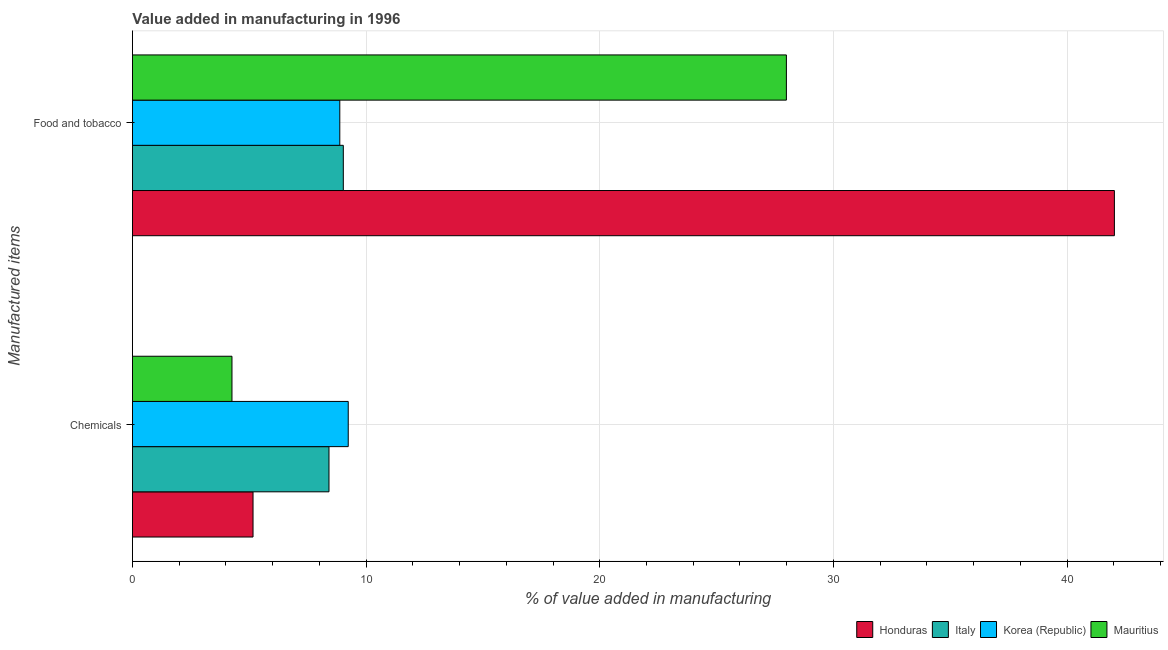How many groups of bars are there?
Offer a terse response. 2. How many bars are there on the 2nd tick from the bottom?
Give a very brief answer. 4. What is the label of the 1st group of bars from the top?
Offer a very short reply. Food and tobacco. What is the value added by  manufacturing chemicals in Honduras?
Offer a terse response. 5.16. Across all countries, what is the maximum value added by  manufacturing chemicals?
Make the answer very short. 9.24. Across all countries, what is the minimum value added by  manufacturing chemicals?
Keep it short and to the point. 4.26. In which country was the value added by  manufacturing chemicals maximum?
Offer a very short reply. Korea (Republic). In which country was the value added by  manufacturing chemicals minimum?
Give a very brief answer. Mauritius. What is the total value added by manufacturing food and tobacco in the graph?
Your response must be concise. 87.91. What is the difference between the value added by manufacturing food and tobacco in Italy and that in Honduras?
Offer a terse response. -33. What is the difference between the value added by manufacturing food and tobacco in Mauritius and the value added by  manufacturing chemicals in Italy?
Offer a terse response. 19.58. What is the average value added by manufacturing food and tobacco per country?
Provide a short and direct response. 21.98. What is the difference between the value added by manufacturing food and tobacco and value added by  manufacturing chemicals in Italy?
Your response must be concise. 0.61. In how many countries, is the value added by  manufacturing chemicals greater than 2 %?
Offer a terse response. 4. What is the ratio of the value added by  manufacturing chemicals in Honduras to that in Korea (Republic)?
Your response must be concise. 0.56. In how many countries, is the value added by manufacturing food and tobacco greater than the average value added by manufacturing food and tobacco taken over all countries?
Keep it short and to the point. 2. What does the 4th bar from the top in Chemicals represents?
Provide a succinct answer. Honduras. How many bars are there?
Give a very brief answer. 8. Are all the bars in the graph horizontal?
Offer a terse response. Yes. How many countries are there in the graph?
Your answer should be compact. 4. What is the difference between two consecutive major ticks on the X-axis?
Ensure brevity in your answer.  10. Are the values on the major ticks of X-axis written in scientific E-notation?
Your answer should be very brief. No. Does the graph contain any zero values?
Offer a very short reply. No. Where does the legend appear in the graph?
Offer a terse response. Bottom right. How are the legend labels stacked?
Provide a succinct answer. Horizontal. What is the title of the graph?
Keep it short and to the point. Value added in manufacturing in 1996. What is the label or title of the X-axis?
Provide a short and direct response. % of value added in manufacturing. What is the label or title of the Y-axis?
Offer a very short reply. Manufactured items. What is the % of value added in manufacturing of Honduras in Chemicals?
Offer a very short reply. 5.16. What is the % of value added in manufacturing of Italy in Chemicals?
Give a very brief answer. 8.41. What is the % of value added in manufacturing of Korea (Republic) in Chemicals?
Provide a short and direct response. 9.24. What is the % of value added in manufacturing of Mauritius in Chemicals?
Keep it short and to the point. 4.26. What is the % of value added in manufacturing in Honduras in Food and tobacco?
Ensure brevity in your answer.  42.03. What is the % of value added in manufacturing in Italy in Food and tobacco?
Your answer should be very brief. 9.03. What is the % of value added in manufacturing in Korea (Republic) in Food and tobacco?
Ensure brevity in your answer.  8.87. What is the % of value added in manufacturing of Mauritius in Food and tobacco?
Keep it short and to the point. 27.99. Across all Manufactured items, what is the maximum % of value added in manufacturing in Honduras?
Your answer should be compact. 42.03. Across all Manufactured items, what is the maximum % of value added in manufacturing of Italy?
Offer a very short reply. 9.03. Across all Manufactured items, what is the maximum % of value added in manufacturing of Korea (Republic)?
Provide a short and direct response. 9.24. Across all Manufactured items, what is the maximum % of value added in manufacturing of Mauritius?
Your answer should be very brief. 27.99. Across all Manufactured items, what is the minimum % of value added in manufacturing in Honduras?
Your answer should be compact. 5.16. Across all Manufactured items, what is the minimum % of value added in manufacturing in Italy?
Offer a very short reply. 8.41. Across all Manufactured items, what is the minimum % of value added in manufacturing of Korea (Republic)?
Provide a succinct answer. 8.87. Across all Manufactured items, what is the minimum % of value added in manufacturing of Mauritius?
Keep it short and to the point. 4.26. What is the total % of value added in manufacturing of Honduras in the graph?
Make the answer very short. 47.19. What is the total % of value added in manufacturing in Italy in the graph?
Provide a succinct answer. 17.44. What is the total % of value added in manufacturing of Korea (Republic) in the graph?
Provide a succinct answer. 18.11. What is the total % of value added in manufacturing in Mauritius in the graph?
Your response must be concise. 32.25. What is the difference between the % of value added in manufacturing in Honduras in Chemicals and that in Food and tobacco?
Ensure brevity in your answer.  -36.86. What is the difference between the % of value added in manufacturing of Italy in Chemicals and that in Food and tobacco?
Your answer should be compact. -0.61. What is the difference between the % of value added in manufacturing of Korea (Republic) in Chemicals and that in Food and tobacco?
Give a very brief answer. 0.36. What is the difference between the % of value added in manufacturing in Mauritius in Chemicals and that in Food and tobacco?
Provide a short and direct response. -23.73. What is the difference between the % of value added in manufacturing in Honduras in Chemicals and the % of value added in manufacturing in Italy in Food and tobacco?
Your response must be concise. -3.86. What is the difference between the % of value added in manufacturing of Honduras in Chemicals and the % of value added in manufacturing of Korea (Republic) in Food and tobacco?
Provide a succinct answer. -3.71. What is the difference between the % of value added in manufacturing of Honduras in Chemicals and the % of value added in manufacturing of Mauritius in Food and tobacco?
Give a very brief answer. -22.83. What is the difference between the % of value added in manufacturing in Italy in Chemicals and the % of value added in manufacturing in Korea (Republic) in Food and tobacco?
Provide a short and direct response. -0.46. What is the difference between the % of value added in manufacturing of Italy in Chemicals and the % of value added in manufacturing of Mauritius in Food and tobacco?
Provide a succinct answer. -19.58. What is the difference between the % of value added in manufacturing in Korea (Republic) in Chemicals and the % of value added in manufacturing in Mauritius in Food and tobacco?
Your answer should be compact. -18.75. What is the average % of value added in manufacturing of Honduras per Manufactured items?
Your answer should be compact. 23.59. What is the average % of value added in manufacturing of Italy per Manufactured items?
Keep it short and to the point. 8.72. What is the average % of value added in manufacturing in Korea (Republic) per Manufactured items?
Your answer should be very brief. 9.06. What is the average % of value added in manufacturing in Mauritius per Manufactured items?
Offer a very short reply. 16.12. What is the difference between the % of value added in manufacturing of Honduras and % of value added in manufacturing of Italy in Chemicals?
Keep it short and to the point. -3.25. What is the difference between the % of value added in manufacturing in Honduras and % of value added in manufacturing in Korea (Republic) in Chemicals?
Provide a succinct answer. -4.07. What is the difference between the % of value added in manufacturing in Honduras and % of value added in manufacturing in Mauritius in Chemicals?
Offer a terse response. 0.9. What is the difference between the % of value added in manufacturing in Italy and % of value added in manufacturing in Korea (Republic) in Chemicals?
Provide a short and direct response. -0.82. What is the difference between the % of value added in manufacturing in Italy and % of value added in manufacturing in Mauritius in Chemicals?
Your answer should be very brief. 4.15. What is the difference between the % of value added in manufacturing in Korea (Republic) and % of value added in manufacturing in Mauritius in Chemicals?
Your response must be concise. 4.98. What is the difference between the % of value added in manufacturing of Honduras and % of value added in manufacturing of Italy in Food and tobacco?
Provide a succinct answer. 33. What is the difference between the % of value added in manufacturing of Honduras and % of value added in manufacturing of Korea (Republic) in Food and tobacco?
Your answer should be compact. 33.15. What is the difference between the % of value added in manufacturing of Honduras and % of value added in manufacturing of Mauritius in Food and tobacco?
Offer a very short reply. 14.04. What is the difference between the % of value added in manufacturing of Italy and % of value added in manufacturing of Korea (Republic) in Food and tobacco?
Offer a very short reply. 0.15. What is the difference between the % of value added in manufacturing in Italy and % of value added in manufacturing in Mauritius in Food and tobacco?
Offer a terse response. -18.96. What is the difference between the % of value added in manufacturing of Korea (Republic) and % of value added in manufacturing of Mauritius in Food and tobacco?
Provide a short and direct response. -19.11. What is the ratio of the % of value added in manufacturing in Honduras in Chemicals to that in Food and tobacco?
Give a very brief answer. 0.12. What is the ratio of the % of value added in manufacturing in Italy in Chemicals to that in Food and tobacco?
Offer a very short reply. 0.93. What is the ratio of the % of value added in manufacturing in Korea (Republic) in Chemicals to that in Food and tobacco?
Your response must be concise. 1.04. What is the ratio of the % of value added in manufacturing in Mauritius in Chemicals to that in Food and tobacco?
Offer a very short reply. 0.15. What is the difference between the highest and the second highest % of value added in manufacturing of Honduras?
Your answer should be very brief. 36.86. What is the difference between the highest and the second highest % of value added in manufacturing in Italy?
Give a very brief answer. 0.61. What is the difference between the highest and the second highest % of value added in manufacturing of Korea (Republic)?
Your response must be concise. 0.36. What is the difference between the highest and the second highest % of value added in manufacturing in Mauritius?
Make the answer very short. 23.73. What is the difference between the highest and the lowest % of value added in manufacturing of Honduras?
Your answer should be compact. 36.86. What is the difference between the highest and the lowest % of value added in manufacturing in Italy?
Ensure brevity in your answer.  0.61. What is the difference between the highest and the lowest % of value added in manufacturing in Korea (Republic)?
Make the answer very short. 0.36. What is the difference between the highest and the lowest % of value added in manufacturing of Mauritius?
Make the answer very short. 23.73. 